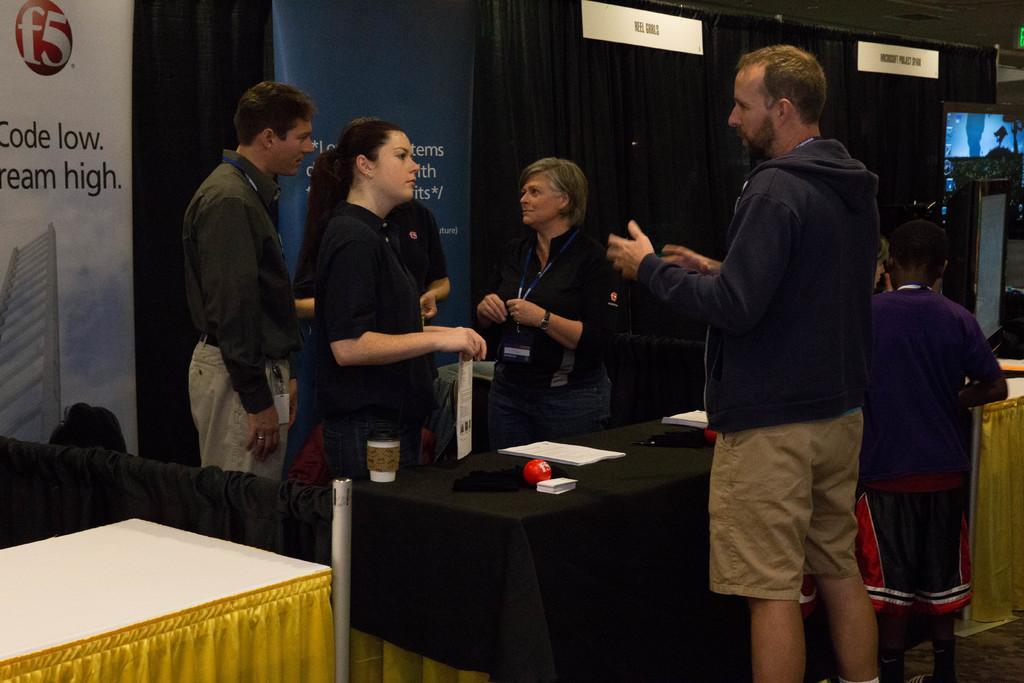Can you describe this image briefly? These persons are standing. This is a black curtain. In-front of this black curtain there are banners. On this table there is a cloth, cup, papers and ball. Far there is a podium. 